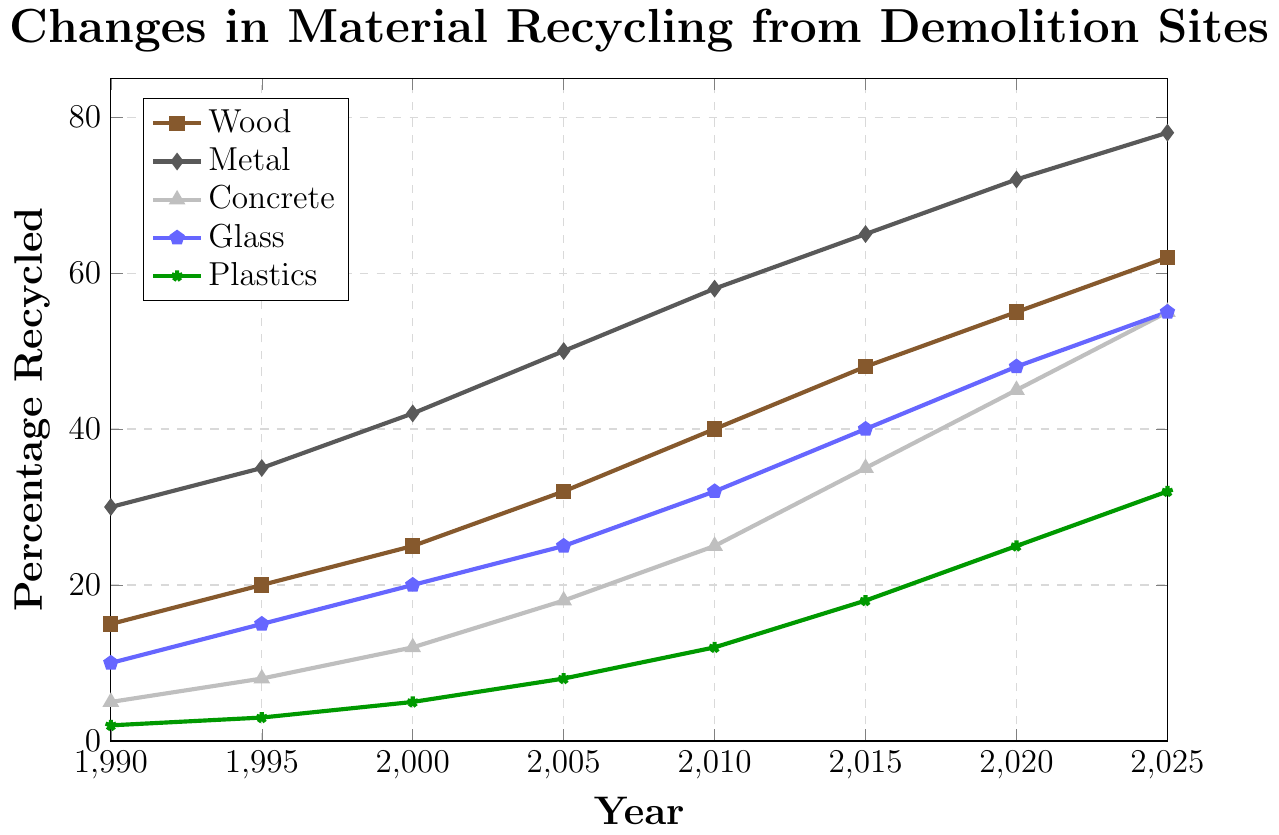What is the percentage increase in recycled Wood from 1990 to 2025? First, observe the percentage of Wood recycled in both 1990 and 2025. In 1990, it's 15%, and in 2025, it's 62%. Calculate the increase: 62% - 15% = 47%.
Answer: 47% Which material had the highest recycling percentage in 2020? Look at the values for each material in 2020. Wood is 55%, Metal is 72%, Concrete is 45%, Glass is 48%, and Plastics is 25%. The highest percentage is for Metal, at 72%.
Answer: Metal By how many percentage points did the recycling percentage of Metal increase from 1995 to 2005? Find the recycling percentages for Metal in 1995 (35%) and 2005 (50%). Calculate the difference: 50% - 35% = 15%.
Answer: 15% Which material had the least percentage recycled in 2010, and by how much did it increase in percent from 1990? In 2010, the percentages are as follows: Wood is 40%, Metal is 58%, Concrete is 25%, Glass is 32%, and Plastics is 12%. The least recycled material in 2010 was Plastics at 12%. In 1990, Plastics were at 2%. The increase is: 12% - 2% = 10%.
Answer: Plastics, 10% Comparing Metal and Glass, which saw a greater increase in recycling percentage from 2000 to 2015? Look at the data for Metal in 2000 (42%) and 2015 (65%), giving an increase of 65% - 42% = 23%. For Glass, in 2000 it's 20% and in 2015 it's 40%, giving an increase of 40% - 20% = 20%. Hence, Metal saw a greater increase.
Answer: Metal In which year did the recycling percentage of Concrete surpass 20%? Check the Concrete percentages for each year. The percentage surpasses 20% between 2005 (18%) and 2010 (25%). Therefore, this happens in 2010.
Answer: 2010 What is the average percentage of recycled Glass over the years provided? The percentages for Glass listed are: 10%, 15%, 20%, 25%, 32%, 40%, 48%, and 55%. Calculate the average: (10 + 15 + 20 + 25 + 32 + 40 + 48 + 55) / 8 = 245 / 8 = 30.625%.
Answer: 30.625% How does the trend of recycling Wood compare to the trend of recycling Plastics over the years? Both Wood and Plastics show an upward trend. Initially, Plastics had a very low recycling percentage, while Wood had a more substantial starting percentage. Over the years, Wood consistently increases, reaching 62% by 2025, whereas Plastics, while also increasing, remains lower, reaching only 32% by 2025.
Answer: Consistently higher for Wood Which material has the most consistent increase in percentage recycled from year to year? Review each material's data. Both Wood and Metal show steady increases, but Metal has a uniform increase across each interval of time.
Answer: Metal What is the total percentage increase for all materials combined from 1990 to 2025? Calculate the increase for each material: 
Wood: 62% - 15% = 47%
Metal: 78% - 30% = 48%
Concrete: 55% - 5% = 50%
Glass: 55% - 10% = 45%
Plastics: 32% - 2% = 30%
Now, sum these increases: 47 + 48 + 50 + 45 + 30 = 220%.
Answer: 220% 